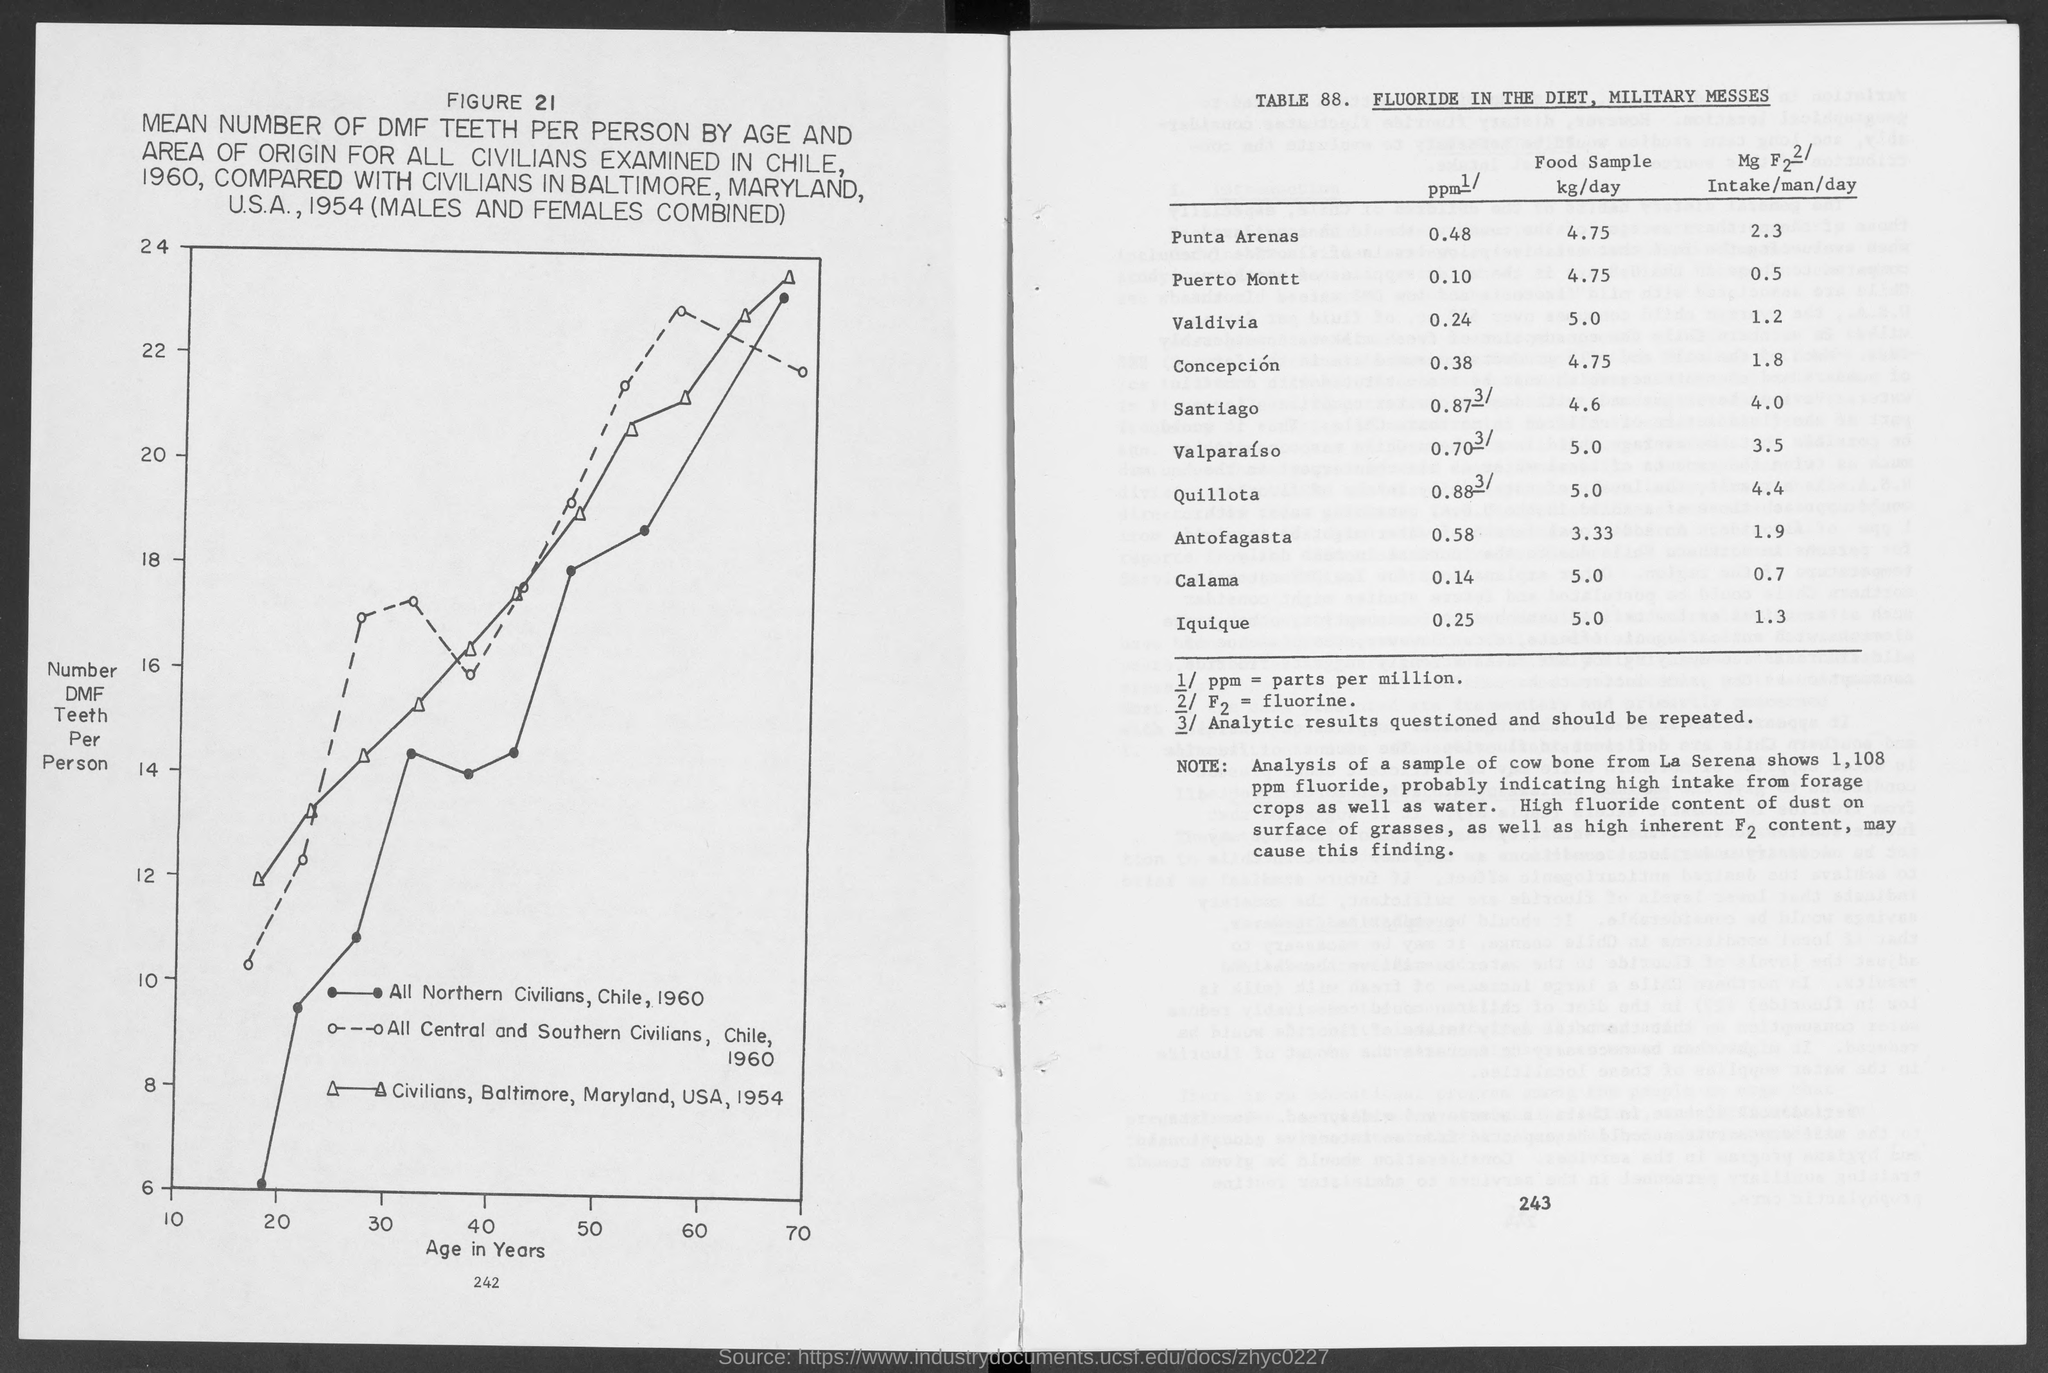Draw attention to some important aspects in this diagram. The variable on the Y axis of the graph in FIGURE 21 is "Number of DMF Teeth Per Person. The sample of cow bone from La Serena showed a high level of fluoride at 1,108 parts per million. A food sample was analyzed in Valdivia, resulting in a daily intake of 5.0 kilograms. Part per million" refers to a unit of measurement used to express the concentration of a substance in a given volume of a solution or substance. The variable on the X axis of the graph in FIGURE 21 is age in years. 